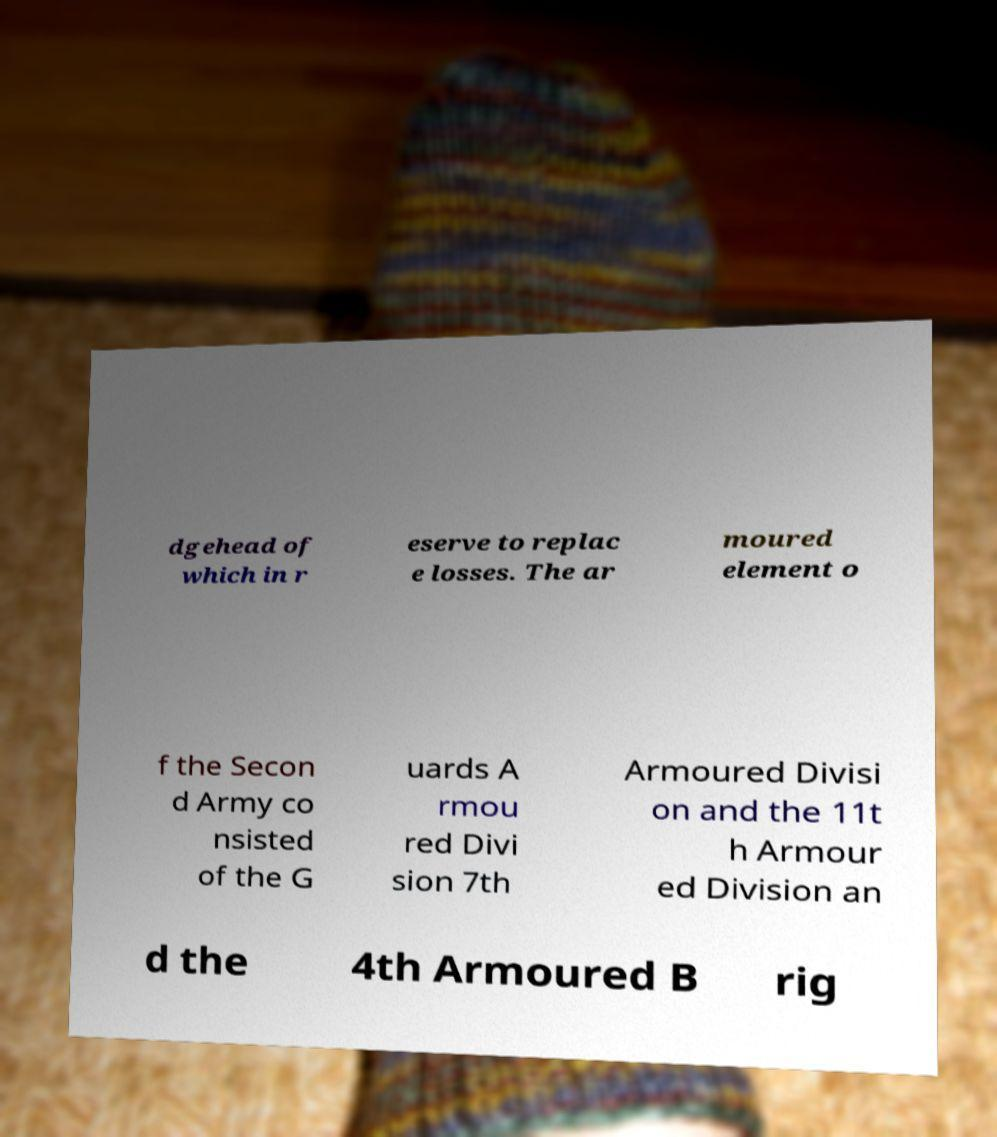Can you accurately transcribe the text from the provided image for me? dgehead of which in r eserve to replac e losses. The ar moured element o f the Secon d Army co nsisted of the G uards A rmou red Divi sion 7th Armoured Divisi on and the 11t h Armour ed Division an d the 4th Armoured B rig 